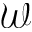<formula> <loc_0><loc_0><loc_500><loc_500>\mathcal { W }</formula> 